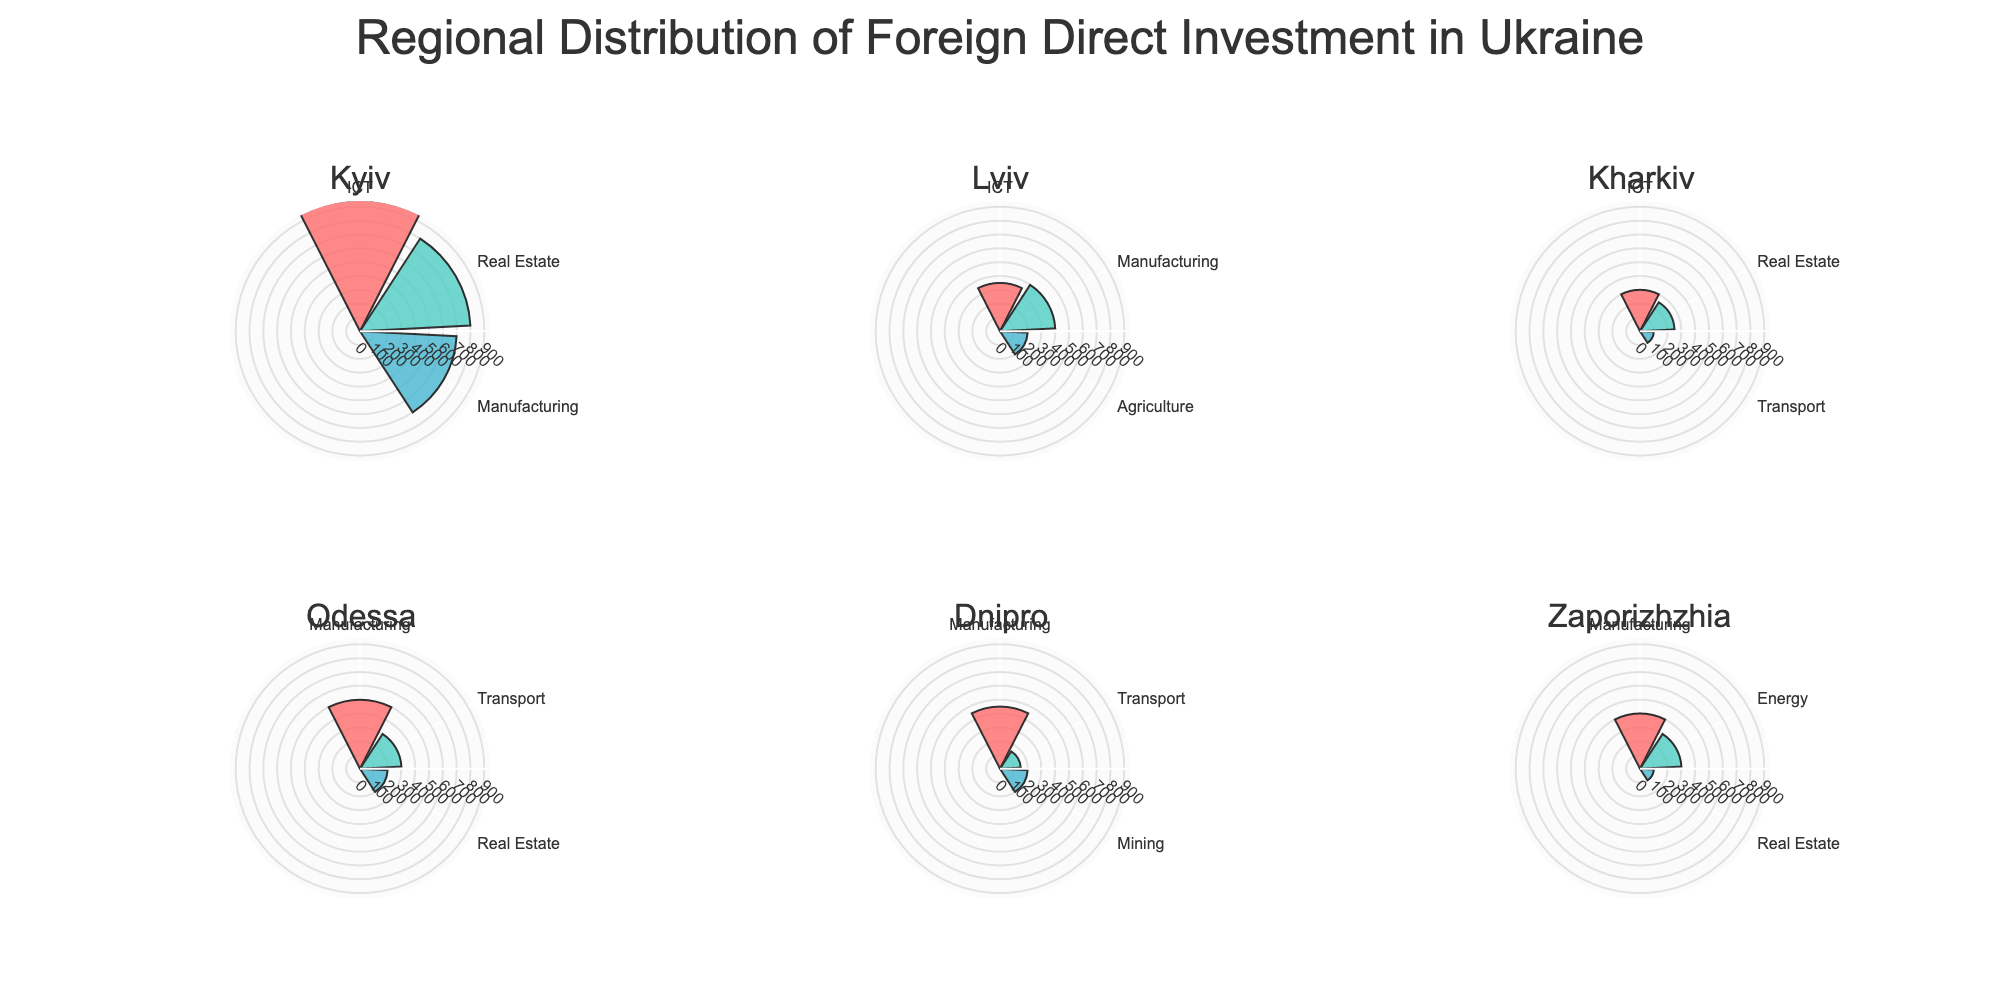What is the title of the figure? The title is displayed at the center-top of the figure, indicating the main theme of the plot.
Answer: Regional Distribution of Foreign Direct Investment in Ukraine Which region received the highest amount of foreign direct investment in the ICT sector? By checking the radial length in the subplot for each region, the tallest bar under the ICT label is in Kyiv's subplot.
Answer: Kyiv How many regions have investments in the Manufacturing sector? Counting the number of subplots that have a bar labeled 'Manufacturing', we find it in the subplots for Kyiv, Lviv, Odessa, Dnipro, and Zaporizhzhia.
Answer: 5 Which industry has the least amount of investment in Kharkiv? In Kharkiv’s subplot, the smallest bar among the industries is identified and it corresponds to the Transport sector.
Answer: Transport What is the total foreign direct investment amount received by Lviv? Sum the investment amounts for all industries in Lviv: 350 (ICT) + 400 (Manufacturing) + 200 (Agriculture) = 950 million USD.
Answer: 950 Which region has more total investment: Odessa or Dnipro? Calculate the total for each region. Odessa: 500 (Manufacturing) + 300 (Transport) + 200 (Real Estate) = 1000; Dnipro: 450 (Manufacturing) + 150 (Transport) + 200 (Mining) = 800. Comparing these totals, Odessa has more.
Answer: Odessa What is the average amount of investment in the Real Estate sector across all regions? Compute the average for the Real Estate amounts in Kyiv, Kharkiv, Odessa, and Zaporizhzhia. (800 + 250 + 200 + 100) / 4 = 1350 / 4 = 337.5 million USD.
Answer: 337.5 Which industry has the highest cumulative investment across all regions? Sum the investment across all regions for each industry. Example for ICT: 950 (Kyiv) + 350 (Lviv) + 300 (Kharkiv) = 1600. Compare with other cumulative sums. Manufacturing has the highest total with 700 (Kyiv) + 400 (Lviv) + 500 (Odessa) + 450 (Dnipro) + 400 (Zaporizhzhia) = 2450.
Answer: Manufacturing What is the proportional difference between ICT investment in Kyiv and Kharkiv? Calculate the proportion (950 - 300) / 950 = 650 / 950 ≈ 0.6842 or 68.42%.
Answer: 68.42% What region has the smallest range of investment amounts across its industries? Identify the range (max - min) for each region's investments and compare. Lviv has the following values: 400 (max) - 200 (min) = 200. This is the smallest range among all regions.
Answer: Lviv 